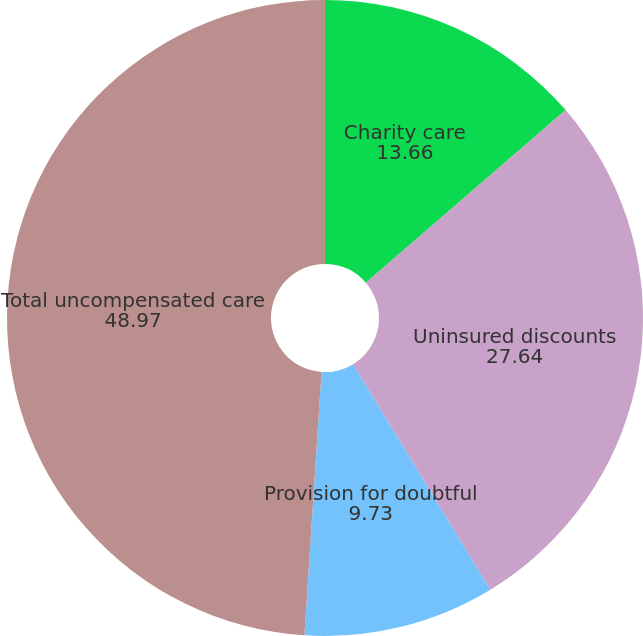<chart> <loc_0><loc_0><loc_500><loc_500><pie_chart><fcel>Charity care<fcel>Uninsured discounts<fcel>Provision for doubtful<fcel>Total uncompensated care<nl><fcel>13.66%<fcel>27.64%<fcel>9.73%<fcel>48.97%<nl></chart> 